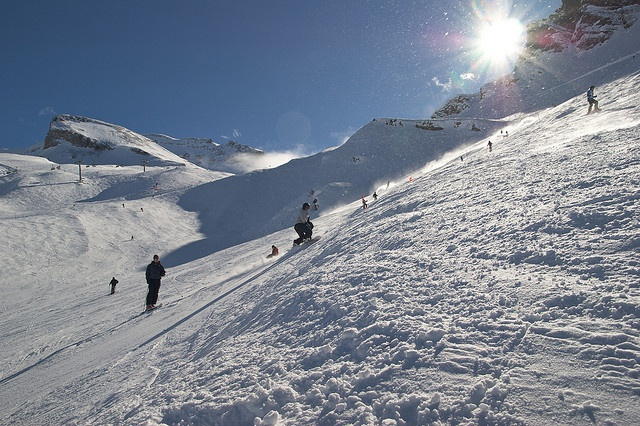Describe the objects in this image and their specific colors. I can see people in darkblue, black, gray, darkgray, and lightgray tones, people in darkblue, black, gray, and darkgray tones, people in darkblue, gray, black, and blue tones, snowboard in darkblue, gray, black, and darkgray tones, and people in darkblue, gray, maroon, black, and darkgray tones in this image. 